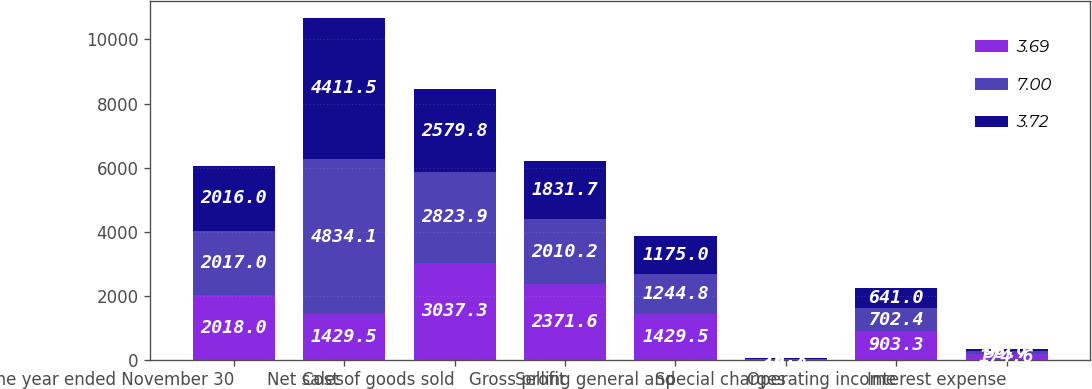Convert chart. <chart><loc_0><loc_0><loc_500><loc_500><stacked_bar_chart><ecel><fcel>for the year ended November 30<fcel>Net sales<fcel>Cost of goods sold<fcel>Gross profit<fcel>Selling general and<fcel>Special charges<fcel>Operating income<fcel>Interest expense<nl><fcel>3.69<fcel>2018<fcel>1429.5<fcel>3037.3<fcel>2371.6<fcel>1429.5<fcel>16.3<fcel>903.3<fcel>174.6<nl><fcel>7<fcel>2017<fcel>4834.1<fcel>2823.9<fcel>2010.2<fcel>1244.8<fcel>22.2<fcel>702.4<fcel>95.7<nl><fcel>3.72<fcel>2016<fcel>4411.5<fcel>2579.8<fcel>1831.7<fcel>1175<fcel>15.7<fcel>641<fcel>56<nl></chart> 